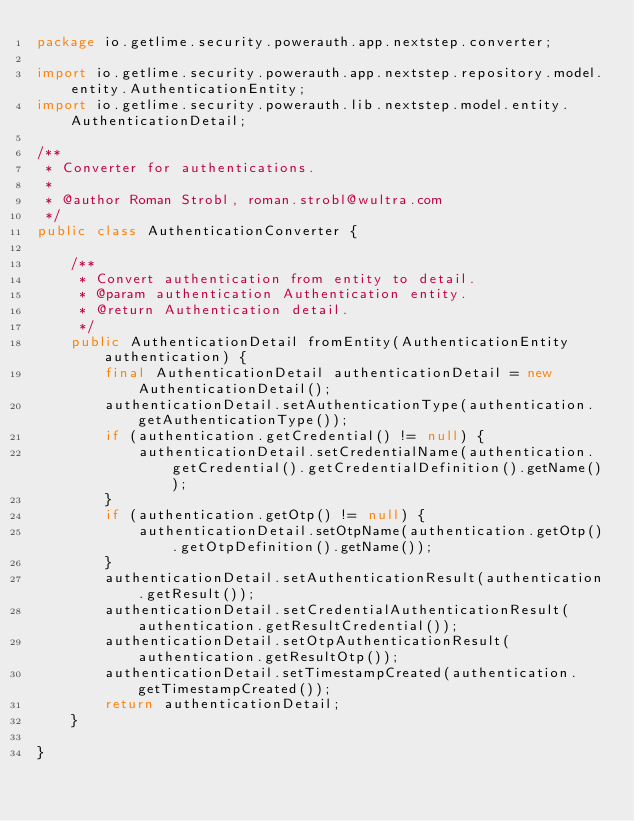Convert code to text. <code><loc_0><loc_0><loc_500><loc_500><_Java_>package io.getlime.security.powerauth.app.nextstep.converter;

import io.getlime.security.powerauth.app.nextstep.repository.model.entity.AuthenticationEntity;
import io.getlime.security.powerauth.lib.nextstep.model.entity.AuthenticationDetail;

/**
 * Converter for authentications.
 *
 * @author Roman Strobl, roman.strobl@wultra.com
 */
public class AuthenticationConverter {

    /**
     * Convert authentication from entity to detail.
     * @param authentication Authentication entity.
     * @return Authentication detail.
     */
    public AuthenticationDetail fromEntity(AuthenticationEntity authentication) {
        final AuthenticationDetail authenticationDetail = new AuthenticationDetail();
        authenticationDetail.setAuthenticationType(authentication.getAuthenticationType());
        if (authentication.getCredential() != null) {
            authenticationDetail.setCredentialName(authentication.getCredential().getCredentialDefinition().getName());
        }
        if (authentication.getOtp() != null) {
            authenticationDetail.setOtpName(authentication.getOtp().getOtpDefinition().getName());
        }
        authenticationDetail.setAuthenticationResult(authentication.getResult());
        authenticationDetail.setCredentialAuthenticationResult(authentication.getResultCredential());
        authenticationDetail.setOtpAuthenticationResult(authentication.getResultOtp());
        authenticationDetail.setTimestampCreated(authentication.getTimestampCreated());
        return authenticationDetail;
    }

}</code> 